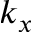Convert formula to latex. <formula><loc_0><loc_0><loc_500><loc_500>k _ { x }</formula> 